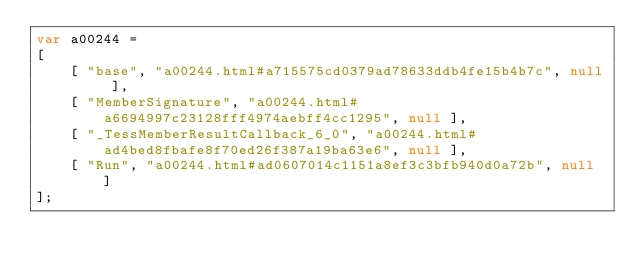<code> <loc_0><loc_0><loc_500><loc_500><_JavaScript_>var a00244 =
[
    [ "base", "a00244.html#a715575cd0379ad78633ddb4fe15b4b7c", null ],
    [ "MemberSignature", "a00244.html#a6694997c23128fff4974aebff4cc1295", null ],
    [ "_TessMemberResultCallback_6_0", "a00244.html#ad4bed8fbafe8f70ed26f387a19ba63e6", null ],
    [ "Run", "a00244.html#ad0607014c1151a8ef3c3bfb940d0a72b", null ]
];</code> 